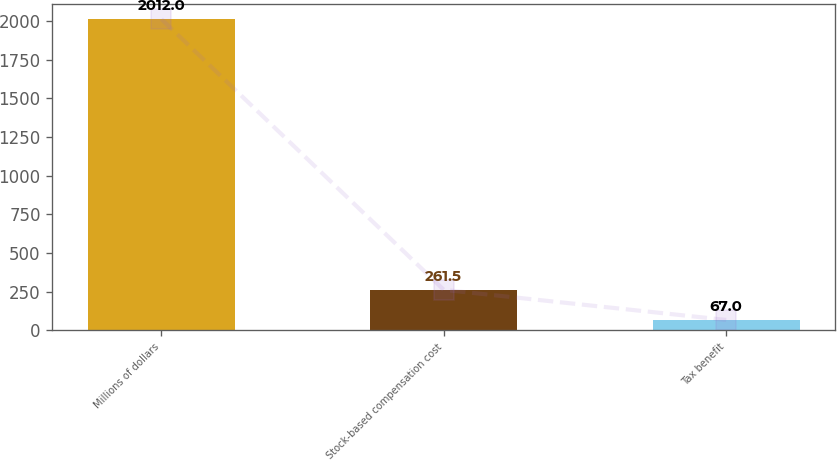Convert chart. <chart><loc_0><loc_0><loc_500><loc_500><bar_chart><fcel>Millions of dollars<fcel>Stock-based compensation cost<fcel>Tax benefit<nl><fcel>2012<fcel>261.5<fcel>67<nl></chart> 